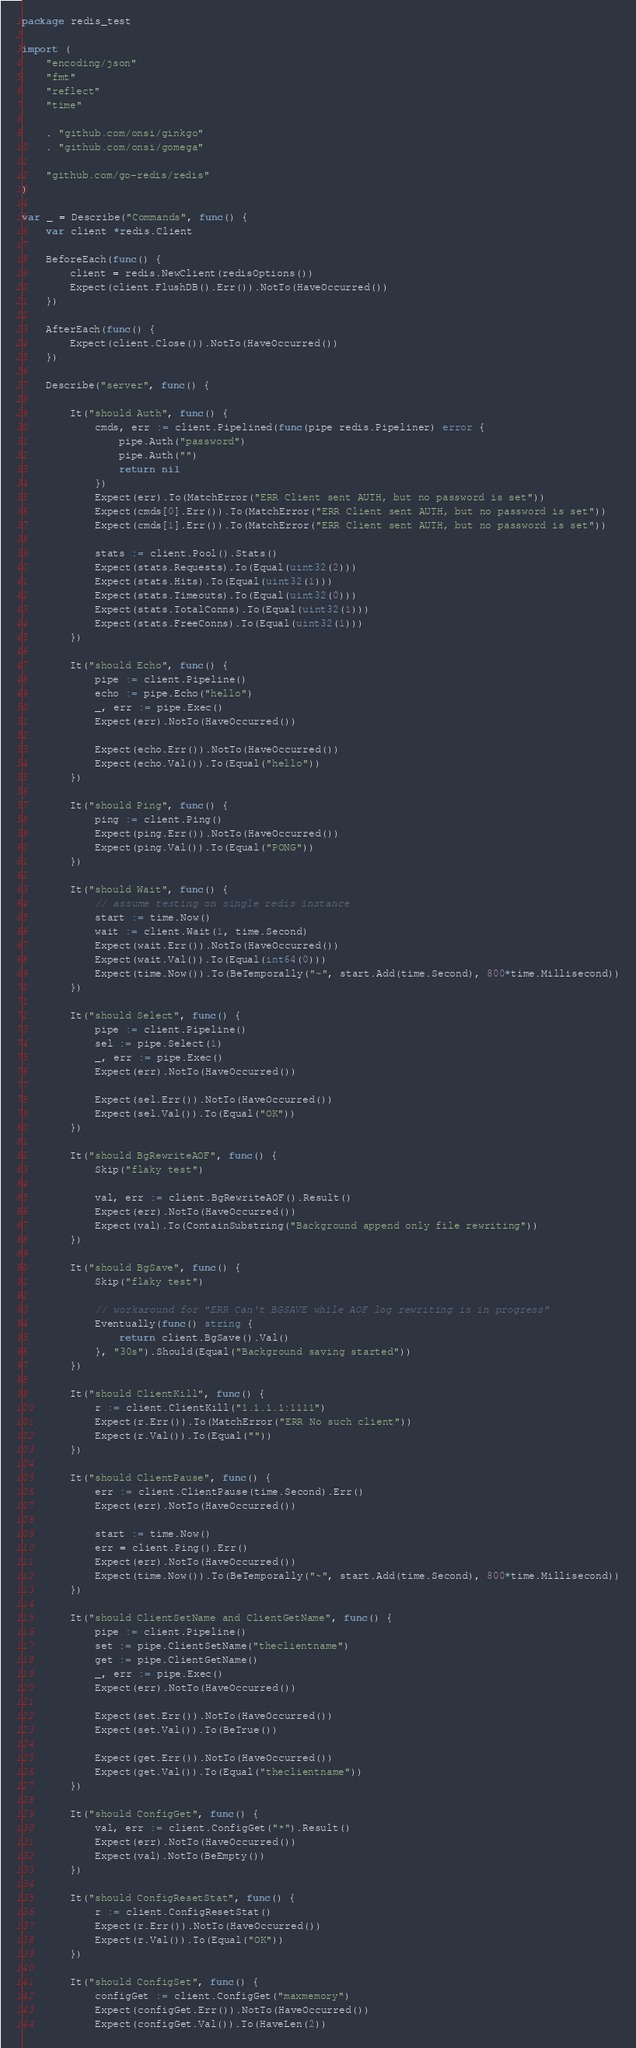<code> <loc_0><loc_0><loc_500><loc_500><_Go_>package redis_test

import (
	"encoding/json"
	"fmt"
	"reflect"
	"time"

	. "github.com/onsi/ginkgo"
	. "github.com/onsi/gomega"

	"github.com/go-redis/redis"
)

var _ = Describe("Commands", func() {
	var client *redis.Client

	BeforeEach(func() {
		client = redis.NewClient(redisOptions())
		Expect(client.FlushDB().Err()).NotTo(HaveOccurred())
	})

	AfterEach(func() {
		Expect(client.Close()).NotTo(HaveOccurred())
	})

	Describe("server", func() {

		It("should Auth", func() {
			cmds, err := client.Pipelined(func(pipe redis.Pipeliner) error {
				pipe.Auth("password")
				pipe.Auth("")
				return nil
			})
			Expect(err).To(MatchError("ERR Client sent AUTH, but no password is set"))
			Expect(cmds[0].Err()).To(MatchError("ERR Client sent AUTH, but no password is set"))
			Expect(cmds[1].Err()).To(MatchError("ERR Client sent AUTH, but no password is set"))

			stats := client.Pool().Stats()
			Expect(stats.Requests).To(Equal(uint32(2)))
			Expect(stats.Hits).To(Equal(uint32(1)))
			Expect(stats.Timeouts).To(Equal(uint32(0)))
			Expect(stats.TotalConns).To(Equal(uint32(1)))
			Expect(stats.FreeConns).To(Equal(uint32(1)))
		})

		It("should Echo", func() {
			pipe := client.Pipeline()
			echo := pipe.Echo("hello")
			_, err := pipe.Exec()
			Expect(err).NotTo(HaveOccurred())

			Expect(echo.Err()).NotTo(HaveOccurred())
			Expect(echo.Val()).To(Equal("hello"))
		})

		It("should Ping", func() {
			ping := client.Ping()
			Expect(ping.Err()).NotTo(HaveOccurred())
			Expect(ping.Val()).To(Equal("PONG"))
		})

		It("should Wait", func() {
			// assume testing on single redis instance
			start := time.Now()
			wait := client.Wait(1, time.Second)
			Expect(wait.Err()).NotTo(HaveOccurred())
			Expect(wait.Val()).To(Equal(int64(0)))
			Expect(time.Now()).To(BeTemporally("~", start.Add(time.Second), 800*time.Millisecond))
		})

		It("should Select", func() {
			pipe := client.Pipeline()
			sel := pipe.Select(1)
			_, err := pipe.Exec()
			Expect(err).NotTo(HaveOccurred())

			Expect(sel.Err()).NotTo(HaveOccurred())
			Expect(sel.Val()).To(Equal("OK"))
		})

		It("should BgRewriteAOF", func() {
			Skip("flaky test")

			val, err := client.BgRewriteAOF().Result()
			Expect(err).NotTo(HaveOccurred())
			Expect(val).To(ContainSubstring("Background append only file rewriting"))
		})

		It("should BgSave", func() {
			Skip("flaky test")

			// workaround for "ERR Can't BGSAVE while AOF log rewriting is in progress"
			Eventually(func() string {
				return client.BgSave().Val()
			}, "30s").Should(Equal("Background saving started"))
		})

		It("should ClientKill", func() {
			r := client.ClientKill("1.1.1.1:1111")
			Expect(r.Err()).To(MatchError("ERR No such client"))
			Expect(r.Val()).To(Equal(""))
		})

		It("should ClientPause", func() {
			err := client.ClientPause(time.Second).Err()
			Expect(err).NotTo(HaveOccurred())

			start := time.Now()
			err = client.Ping().Err()
			Expect(err).NotTo(HaveOccurred())
			Expect(time.Now()).To(BeTemporally("~", start.Add(time.Second), 800*time.Millisecond))
		})

		It("should ClientSetName and ClientGetName", func() {
			pipe := client.Pipeline()
			set := pipe.ClientSetName("theclientname")
			get := pipe.ClientGetName()
			_, err := pipe.Exec()
			Expect(err).NotTo(HaveOccurred())

			Expect(set.Err()).NotTo(HaveOccurred())
			Expect(set.Val()).To(BeTrue())

			Expect(get.Err()).NotTo(HaveOccurred())
			Expect(get.Val()).To(Equal("theclientname"))
		})

		It("should ConfigGet", func() {
			val, err := client.ConfigGet("*").Result()
			Expect(err).NotTo(HaveOccurred())
			Expect(val).NotTo(BeEmpty())
		})

		It("should ConfigResetStat", func() {
			r := client.ConfigResetStat()
			Expect(r.Err()).NotTo(HaveOccurred())
			Expect(r.Val()).To(Equal("OK"))
		})

		It("should ConfigSet", func() {
			configGet := client.ConfigGet("maxmemory")
			Expect(configGet.Err()).NotTo(HaveOccurred())
			Expect(configGet.Val()).To(HaveLen(2))</code> 